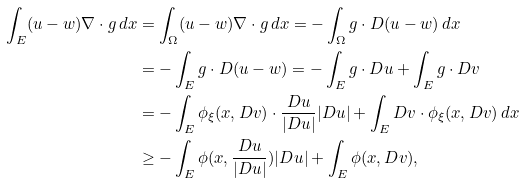<formula> <loc_0><loc_0><loc_500><loc_500>\int _ { E } ( u - w ) \nabla \cdot g \, d x & = \int _ { \Omega } ( u - w ) \nabla \cdot g \, d x = - \int _ { \Omega } g \cdot D ( u - w ) \, d x \\ & = - \int _ { E } g \cdot D ( u - w ) = - \int _ { E } g \cdot D u + \int _ { E } g \cdot D v \\ & = - \int _ { E } \phi _ { \xi } ( x , D v ) \cdot \frac { D u } { | D u | } | D u | + \int _ { E } D v \cdot \phi _ { \xi } ( x , D v ) \, d x \\ & \geq - \int _ { E } \phi ( x , \frac { D u } { | D u | } ) | D u | + \int _ { E } \phi ( x , D v ) ,</formula> 